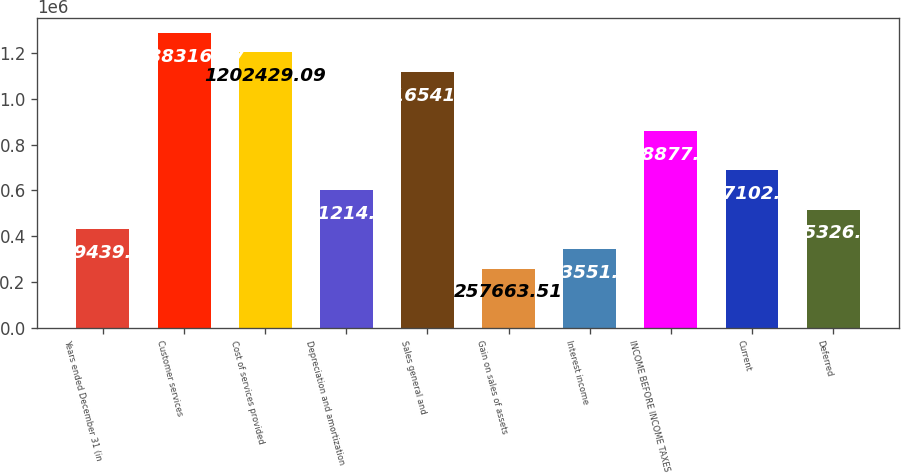Convert chart to OTSL. <chart><loc_0><loc_0><loc_500><loc_500><bar_chart><fcel>Years ended December 31 (in<fcel>Customer services<fcel>Cost of services provided<fcel>Depreciation and amortization<fcel>Sales general and<fcel>Gain on sales of assets<fcel>Interest income<fcel>INCOME BEFORE INCOME TAXES<fcel>Current<fcel>Deferred<nl><fcel>429439<fcel>1.28832e+06<fcel>1.20243e+06<fcel>601215<fcel>1.11654e+06<fcel>257664<fcel>343551<fcel>858878<fcel>687102<fcel>515327<nl></chart> 